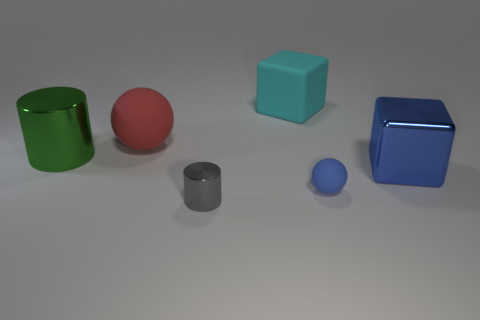The small object that is the same material as the green cylinder is what color? The small object you're referring to appears to be a small sphere, and it shares the same smooth, reflective material as the large green cylinder. It is gray in color. 